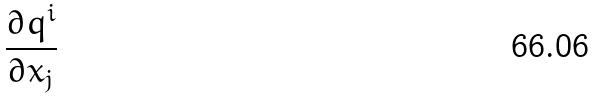Convert formula to latex. <formula><loc_0><loc_0><loc_500><loc_500>\frac { \partial q ^ { i } } { \partial x _ { j } }</formula> 